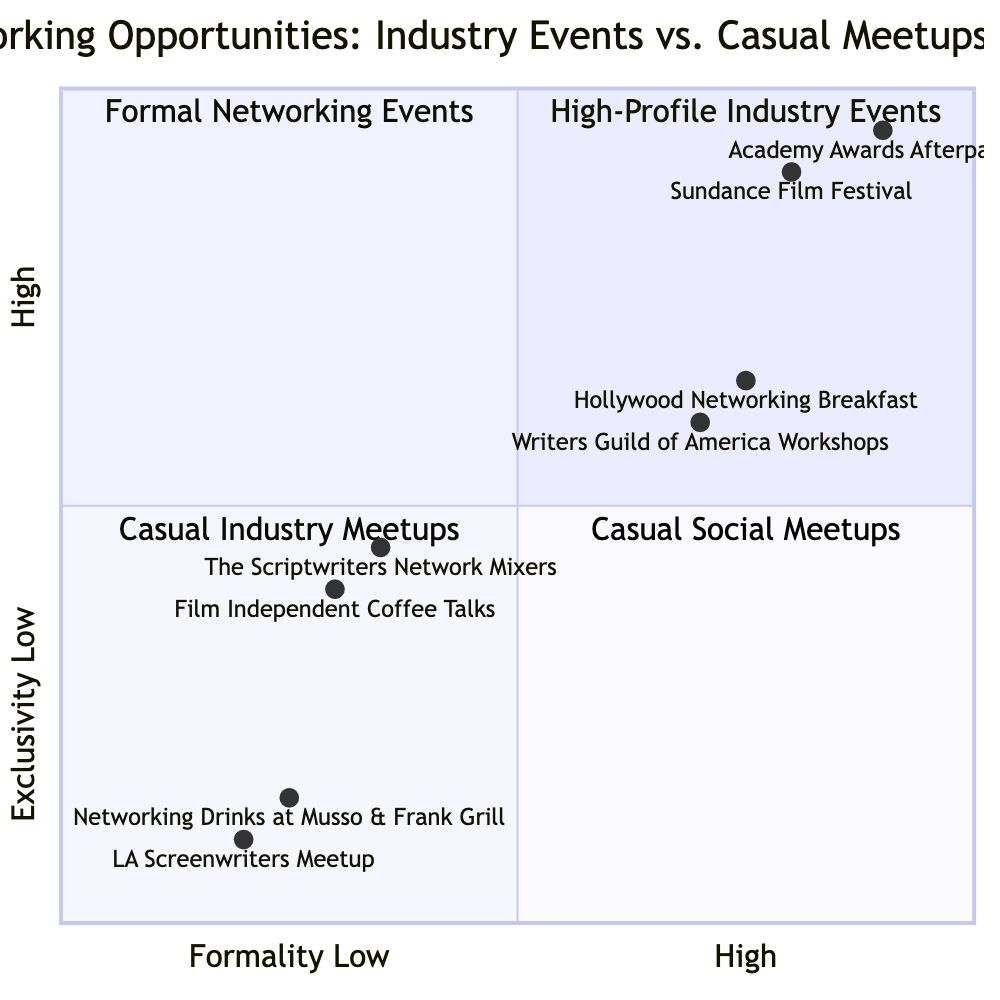What is the most exclusive event listed in the diagram? The most exclusive event is located in the Top-Left quadrant, which is where the "Sundance Film Festival" is positioned. This event scores high on exclusivity with a value of 0.9.
Answer: Sundance Film Festival How many types of events are categorized in the Bottom-Right quadrant? The Bottom-Right quadrant contains two events, "LA Screenwriters Meetup" and "Networking Drinks at Musso & Frank Grill." Thus, the count of events is two.
Answer: 2 Which event has the highest formality score? "Academy Awards Afterparties" is in the Top-Left quadrant, where it has the highest formality score of 0.95, making it the most formal event in the diagram.
Answer: Academy Awards Afterparties What is the relationship between "Writers Guild of America Workshops" and "Film Independent Coffee Talks"? "Writers Guild of America Workshops" is found in the Top-Right quadrant, while "Film Independent Coffee Talks" is in the Bottom-Left quadrant. They represent contrasting levels of exclusivity and formality, with the former being more formal and exclusive than the latter.
Answer: Contrasting Which quadrant contains casual meetups with a supportive community? The Bottom-Right quadrant lists "LA Screenwriters Meetup," which is characterized as an informal gathering and describes a supportive community. Therefore, this is where casual meetups with such features are found.
Answer: Bottom-Right Identify an event that requires membership to attend. In the Top-Right quadrant, the "Writers Guild of America Workshops" requires membership for attendees, distinguishing it as an event with access limitations.
Answer: Writers Guild of America Workshops 